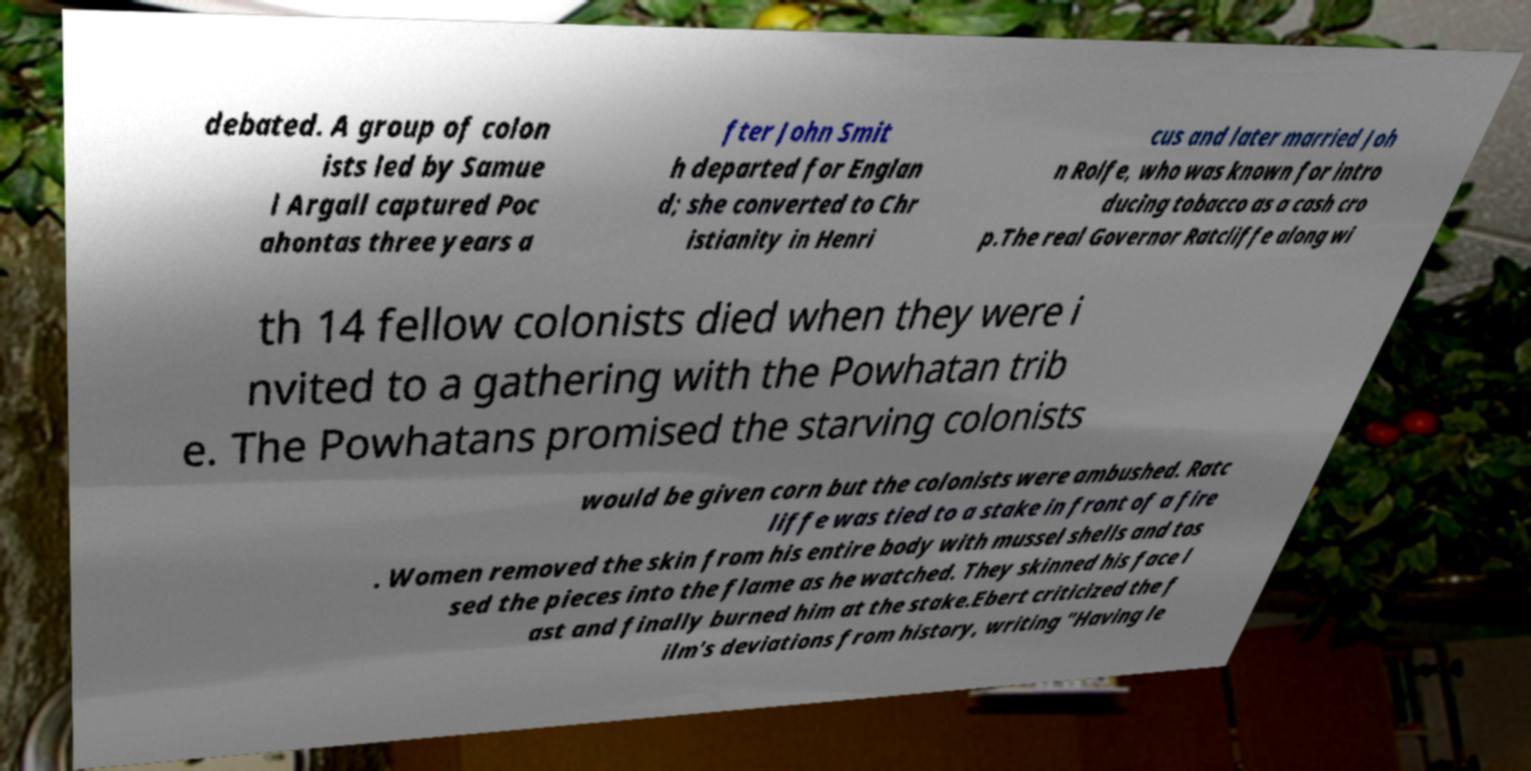Can you accurately transcribe the text from the provided image for me? debated. A group of colon ists led by Samue l Argall captured Poc ahontas three years a fter John Smit h departed for Englan d; she converted to Chr istianity in Henri cus and later married Joh n Rolfe, who was known for intro ducing tobacco as a cash cro p.The real Governor Ratcliffe along wi th 14 fellow colonists died when they were i nvited to a gathering with the Powhatan trib e. The Powhatans promised the starving colonists would be given corn but the colonists were ambushed. Ratc liffe was tied to a stake in front of a fire . Women removed the skin from his entire body with mussel shells and tos sed the pieces into the flame as he watched. They skinned his face l ast and finally burned him at the stake.Ebert criticized the f ilm's deviations from history, writing "Having le 